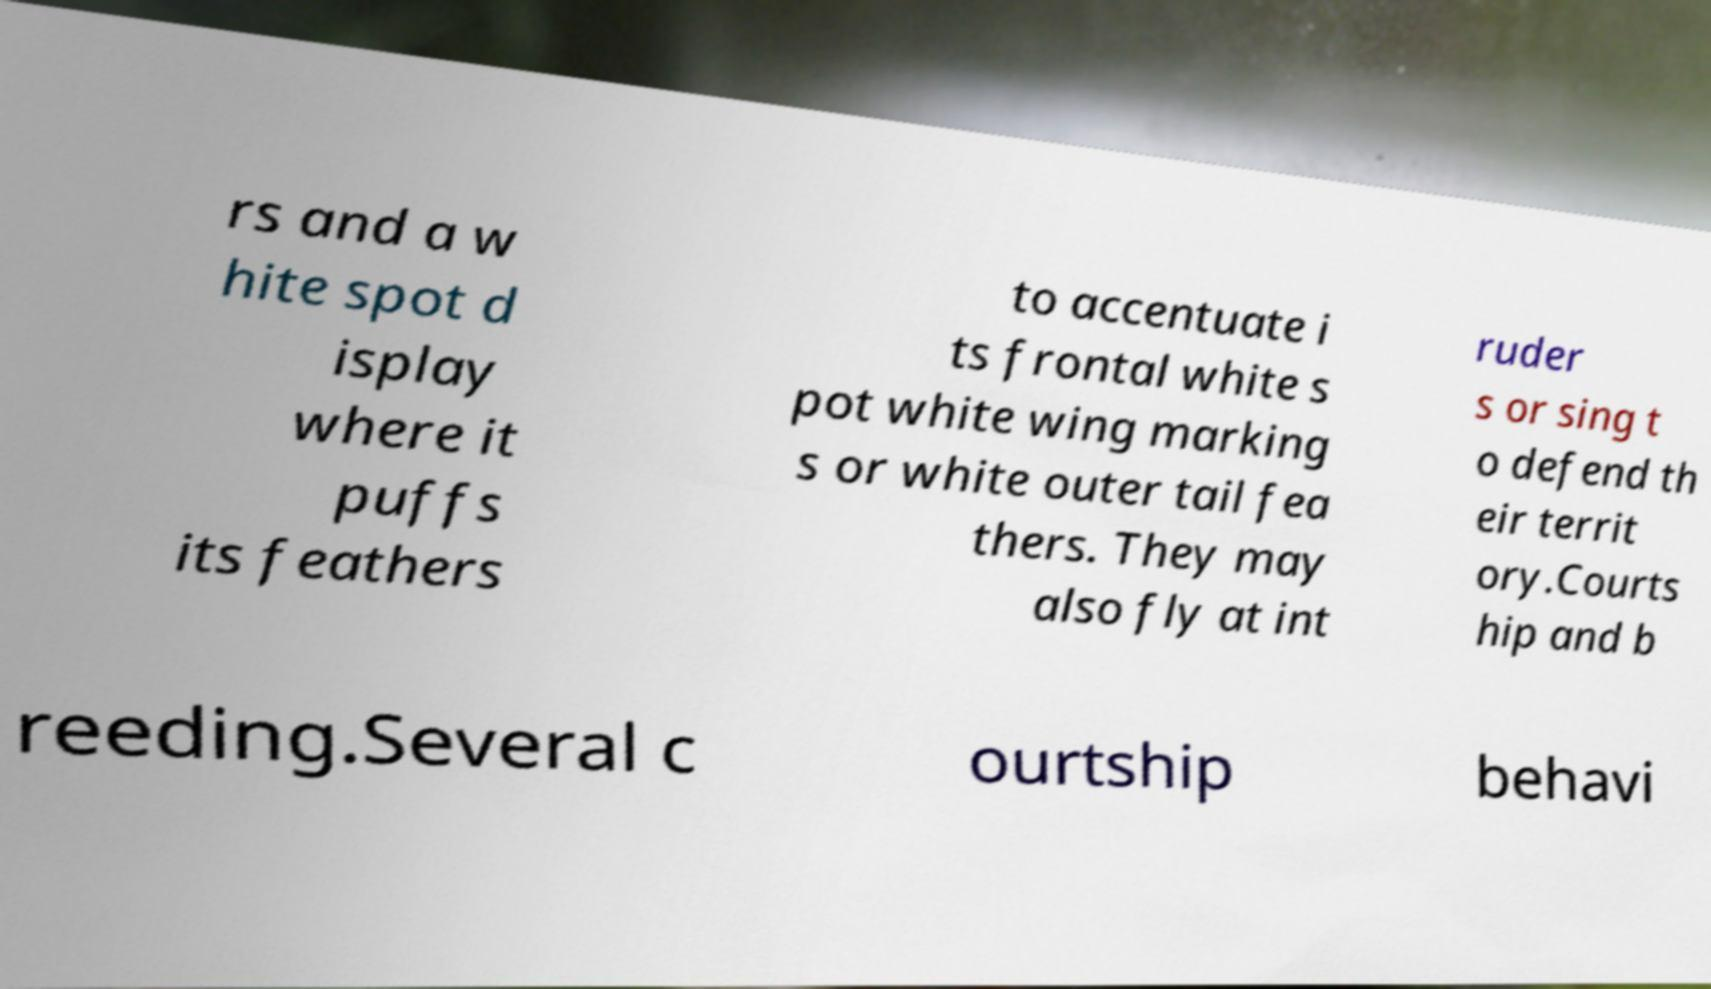Please read and relay the text visible in this image. What does it say? rs and a w hite spot d isplay where it puffs its feathers to accentuate i ts frontal white s pot white wing marking s or white outer tail fea thers. They may also fly at int ruder s or sing t o defend th eir territ ory.Courts hip and b reeding.Several c ourtship behavi 